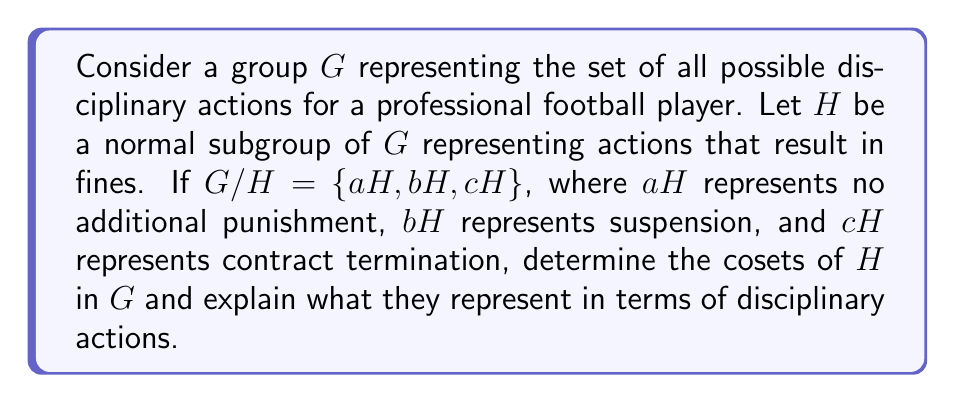Provide a solution to this math problem. To solve this problem, we need to understand the concept of cosets and their significance in the context of disciplinary actions for a professional football player.

1) First, recall that for a subgroup $H$ of a group $G$, the left cosets of $H$ in $G$ are sets of the form $gH = \{gh : h \in H\}$ for $g \in G$. When $H$ is normal in $G$, left and right cosets coincide.

2) In this case, $G/H$ represents the quotient group, which has three elements: $aH$, $bH$, and $cH$. These are the distinct cosets of $H$ in $G$.

3) Each coset represents a class of disciplinary actions that are equivalent modulo fines. In other words, actions within the same coset differ only by the amount of the fine imposed.

4) $aH$ represents the coset of actions that result in only a fine, with no additional punishment. This includes the identity element (no punishment) and various levels of fines.

5) $bH$ represents the coset of actions that result in a suspension plus a fine. Different elements in this coset might represent suspensions of different durations, each potentially accompanied by a fine.

6) $cH$ represents the coset of actions that result in contract termination plus a fine. This is the most severe class of punishments.

7) The normality of $H$ ensures that these disciplinary categories are well-defined and consistent, regardless of the specific violation or the player involved.
Answer: The cosets of $H$ in $G$ are $aH$, $bH$, and $cH$, representing:

$aH$: Actions resulting in fines only
$bH$: Actions resulting in suspension plus a fine
$cH$: Actions resulting in contract termination plus a fine

Each coset represents a distinct category of disciplinary action, with elements within each coset differing only by the specific amount of the associated fine. 